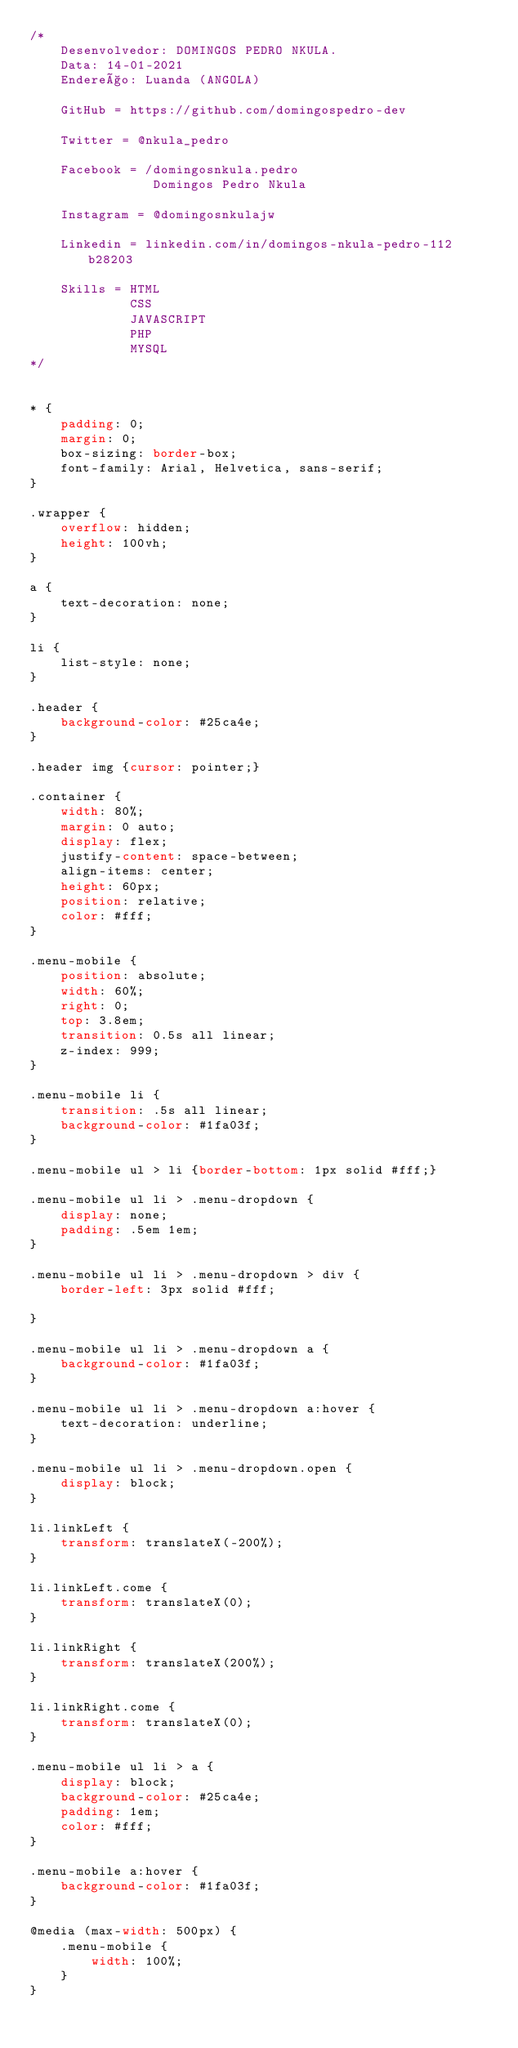Convert code to text. <code><loc_0><loc_0><loc_500><loc_500><_CSS_>/*
    Desenvolvedor: DOMINGOS PEDRO NKULA.
    Data: 14-01-2021
    Endereço: Luanda (ANGOLA)

    GitHub = https://github.com/domingospedro-dev

    Twitter = @nkula_pedro

    Facebook = /domingosnkula.pedro
                Domingos Pedro Nkula

    Instagram = @domingosnkulajw

    Linkedin = linkedin.com/in/domingos-nkula-pedro-112b28203

    Skills = HTML
             CSS
             JAVASCRIPT
             PHP
             MYSQL
*/


* {
    padding: 0;
    margin: 0;
    box-sizing: border-box;
    font-family: Arial, Helvetica, sans-serif;
}

.wrapper {
    overflow: hidden;
    height: 100vh;
}

a {
    text-decoration: none;
}

li {
    list-style: none;
}

.header {
    background-color: #25ca4e;
}

.header img {cursor: pointer;}

.container {
    width: 80%;
    margin: 0 auto;
    display: flex;
    justify-content: space-between;
    align-items: center;
    height: 60px;
    position: relative;
    color: #fff;
}

.menu-mobile {
    position: absolute;
    width: 60%;
    right: 0;
    top: 3.8em;
    transition: 0.5s all linear;
    z-index: 999;
}

.menu-mobile li {
    transition: .5s all linear;
    background-color: #1fa03f;   
}

.menu-mobile ul > li {border-bottom: 1px solid #fff;}

.menu-mobile ul li > .menu-dropdown {
    display: none;
    padding: .5em 1em;
}

.menu-mobile ul li > .menu-dropdown > div {
    border-left: 3px solid #fff;

}

.menu-mobile ul li > .menu-dropdown a {
    background-color: #1fa03f;
}

.menu-mobile ul li > .menu-dropdown a:hover {
    text-decoration: underline;
}

.menu-mobile ul li > .menu-dropdown.open {
    display: block;
}

li.linkLeft {
    transform: translateX(-200%);
}

li.linkLeft.come {
    transform: translateX(0);
}

li.linkRight {
    transform: translateX(200%);
}

li.linkRight.come {
    transform: translateX(0);
}

.menu-mobile ul li > a {
    display: block;
    background-color: #25ca4e;
    padding: 1em;
    color: #fff;
}

.menu-mobile a:hover {
    background-color: #1fa03f;
}

@media (max-width: 500px) {
    .menu-mobile {
        width: 100%;
    }
}</code> 